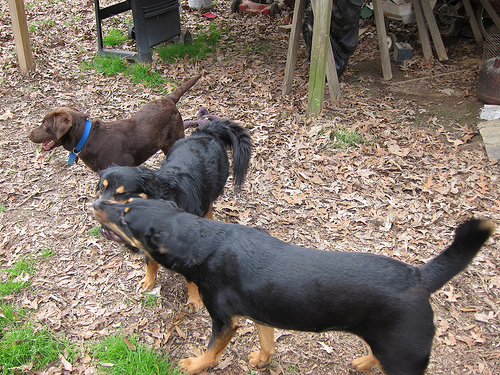<image>
Can you confirm if the dog is behind the dog? Yes. From this viewpoint, the dog is positioned behind the dog, with the dog partially or fully occluding the dog. Where is the dog in relation to the grace? Is it next to the grace? No. The dog is not positioned next to the grace. They are located in different areas of the scene. 